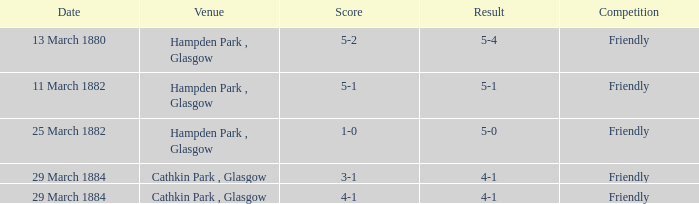Which object holds a 5-1 score? 5-1. 